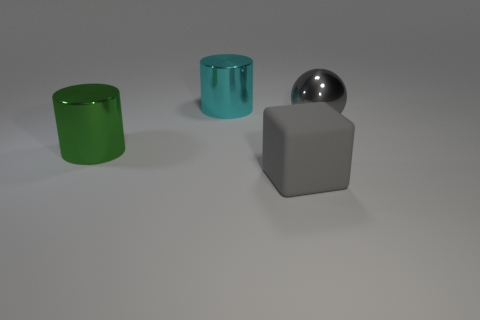What is the size of the metal object that is on the right side of the large green metallic object and left of the large gray metallic thing?
Provide a short and direct response. Large. How many big cyan metal spheres are there?
Your answer should be compact. 0. There is another gray object that is the same size as the matte object; what material is it?
Make the answer very short. Metal. Are there any red objects of the same size as the gray metal sphere?
Your answer should be very brief. No. Does the large object that is on the left side of the big cyan thing have the same color as the metal object right of the large cyan cylinder?
Ensure brevity in your answer.  No. How many metal objects are either gray balls or gray cubes?
Make the answer very short. 1. There is a big gray thing behind the big cylinder to the left of the cyan cylinder; how many rubber things are right of it?
Keep it short and to the point. 0. There is a cyan cylinder that is made of the same material as the big ball; what size is it?
Provide a short and direct response. Large. What number of shiny things have the same color as the cube?
Your answer should be compact. 1. Is the size of the cylinder behind the green object the same as the gray ball?
Your answer should be very brief. Yes. 